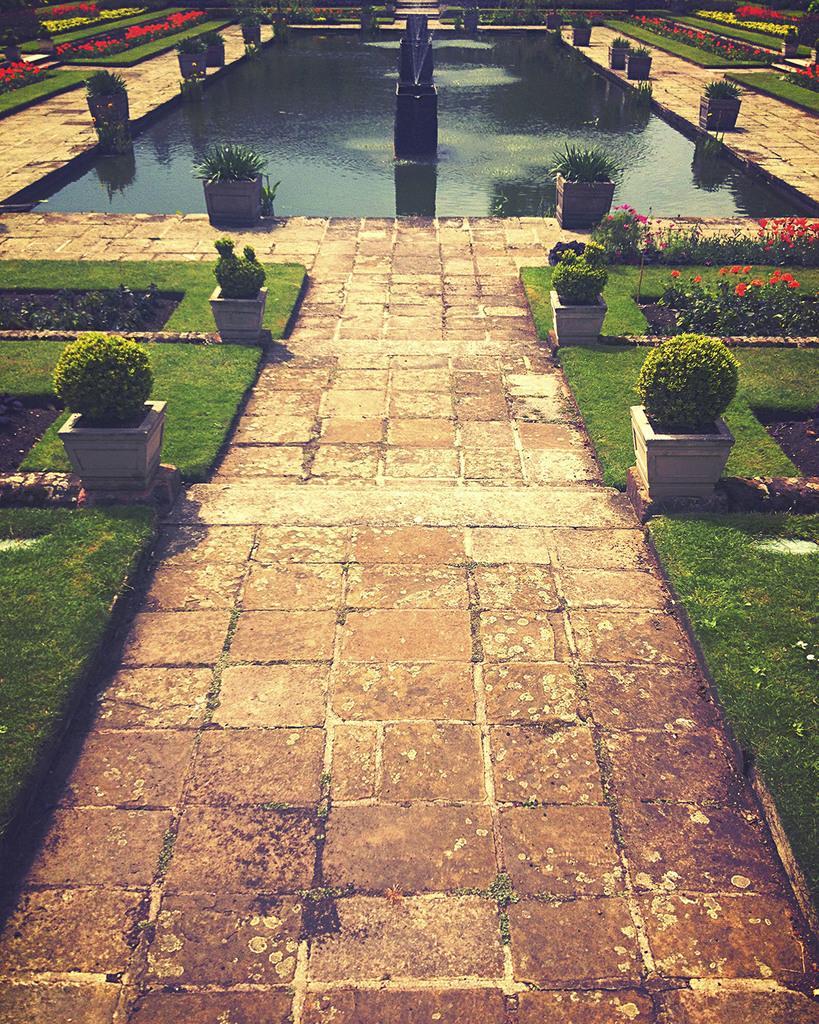Describe this image in one or two sentences. In this image I can see a park or a garden decorated with grass and potted plants. In the center of the image I can see a way accessing a water pond with a fountain.  